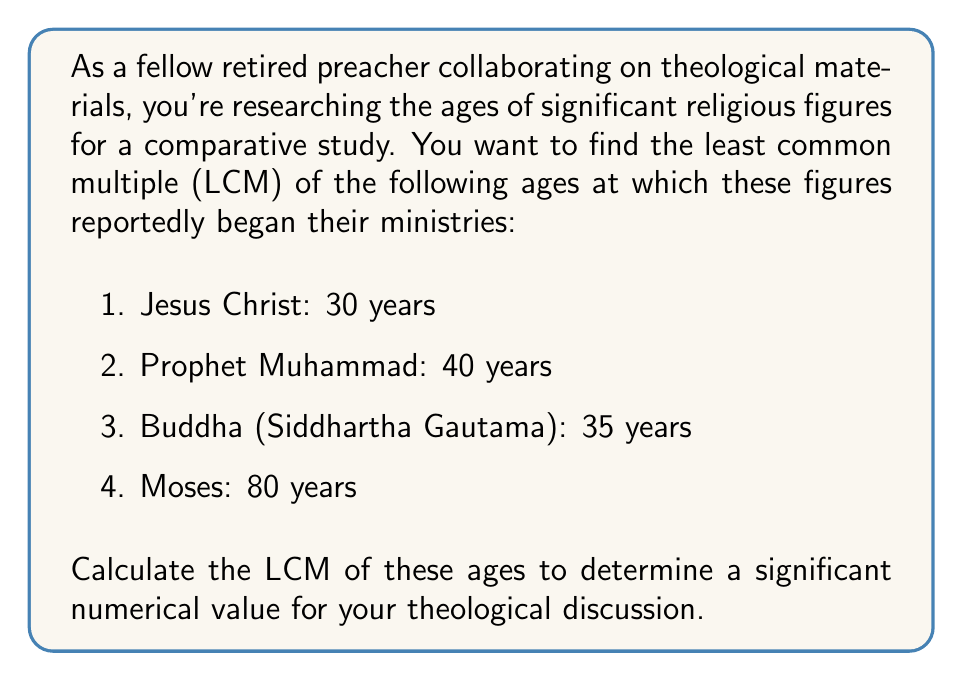Provide a solution to this math problem. To find the LCM of 30, 40, 35, and 80, we'll use the following steps:

1. First, let's find the prime factorization of each number:

   $30 = 2 \cdot 3 \cdot 5$
   $40 = 2^3 \cdot 5$
   $35 = 5 \cdot 7$
   $80 = 2^4 \cdot 5$

2. The LCM will include the highest power of each prime factor from any of the numbers. Let's identify these:

   $2^4$ (from 80)
   $3^1$ (from 30)
   $5^1$ (from all)
   $7^1$ (from 35)

3. Now, we multiply these highest powers:

   $LCM = 2^4 \cdot 3^1 \cdot 5^1 \cdot 7^1$

4. Let's calculate this:

   $LCM = 16 \cdot 3 \cdot 5 \cdot 7$
   $LCM = 48 \cdot 35$
   $LCM = 1680$

Therefore, the least common multiple of 30, 40, 35, and 80 is 1680.
Answer: $1680$ 